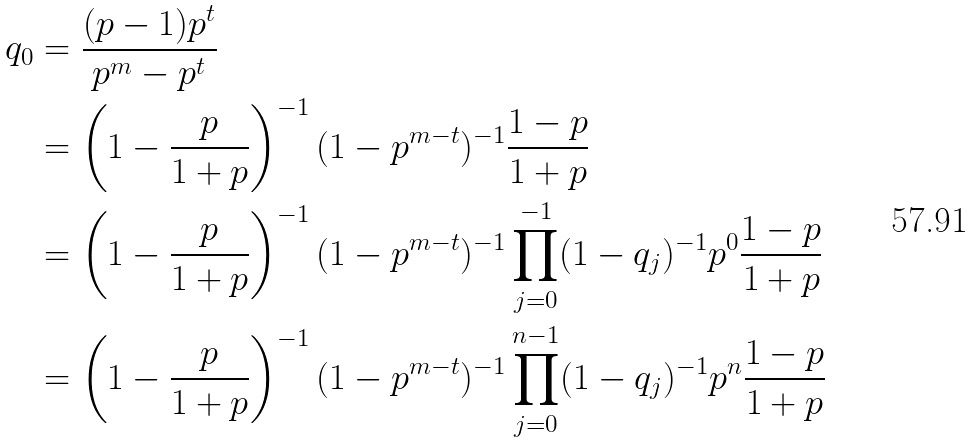Convert formula to latex. <formula><loc_0><loc_0><loc_500><loc_500>q _ { 0 } & = \frac { ( p - 1 ) p ^ { t } } { p ^ { m } - p ^ { t } } \\ & = \left ( 1 - \frac { p } { 1 + p } \right ) ^ { - 1 } ( 1 - p ^ { m - t } ) ^ { - 1 } \frac { 1 - p } { 1 + p } \\ & = \left ( 1 - \frac { p } { 1 + p } \right ) ^ { - 1 } ( 1 - p ^ { m - t } ) ^ { - 1 } \prod _ { j = 0 } ^ { - 1 } ( 1 - q _ { j } ) ^ { - 1 } p ^ { 0 } \frac { 1 - p } { 1 + p } \\ & = \left ( 1 - \frac { p } { 1 + p } \right ) ^ { - 1 } ( 1 - p ^ { m - t } ) ^ { - 1 } \prod _ { j = 0 } ^ { n - 1 } ( 1 - q _ { j } ) ^ { - 1 } p ^ { n } \frac { 1 - p } { 1 + p }</formula> 